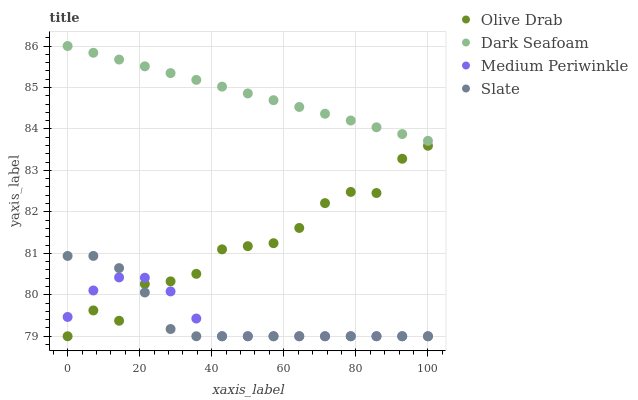Does Medium Periwinkle have the minimum area under the curve?
Answer yes or no. Yes. Does Dark Seafoam have the maximum area under the curve?
Answer yes or no. Yes. Does Slate have the minimum area under the curve?
Answer yes or no. No. Does Slate have the maximum area under the curve?
Answer yes or no. No. Is Dark Seafoam the smoothest?
Answer yes or no. Yes. Is Olive Drab the roughest?
Answer yes or no. Yes. Is Medium Periwinkle the smoothest?
Answer yes or no. No. Is Medium Periwinkle the roughest?
Answer yes or no. No. Does Medium Periwinkle have the lowest value?
Answer yes or no. Yes. Does Dark Seafoam have the highest value?
Answer yes or no. Yes. Does Slate have the highest value?
Answer yes or no. No. Is Slate less than Dark Seafoam?
Answer yes or no. Yes. Is Dark Seafoam greater than Slate?
Answer yes or no. Yes. Does Medium Periwinkle intersect Slate?
Answer yes or no. Yes. Is Medium Periwinkle less than Slate?
Answer yes or no. No. Is Medium Periwinkle greater than Slate?
Answer yes or no. No. Does Slate intersect Dark Seafoam?
Answer yes or no. No. 